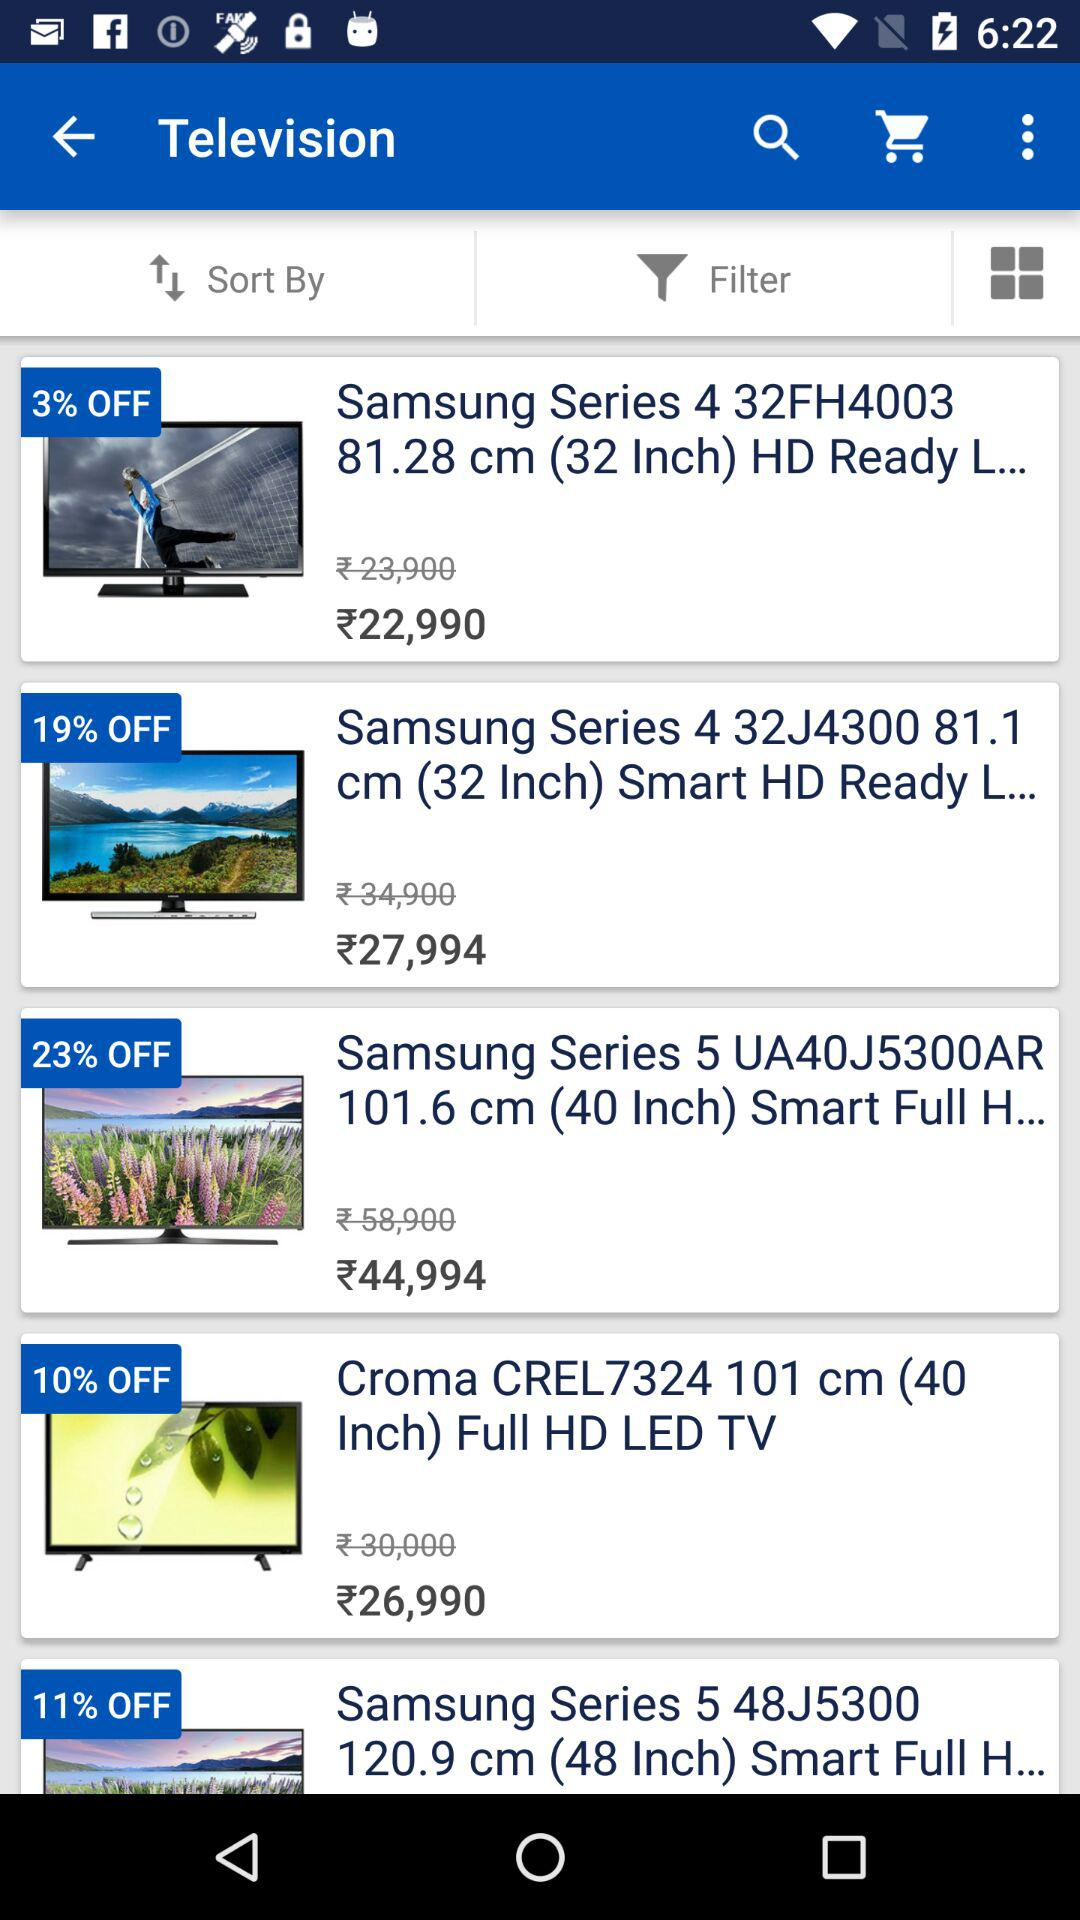How many TVs are on sale that are less than Rs. 30,000?
Answer the question using a single word or phrase. 3 